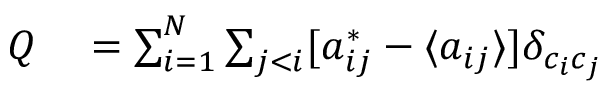Convert formula to latex. <formula><loc_0><loc_0><loc_500><loc_500>\begin{array} { r l } { Q } & = \sum _ { i = 1 } ^ { N } \sum _ { j < i } [ a _ { i j } ^ { * } - \langle a _ { i j } \rangle ] \delta _ { c _ { i } c _ { j } } } \end{array}</formula> 